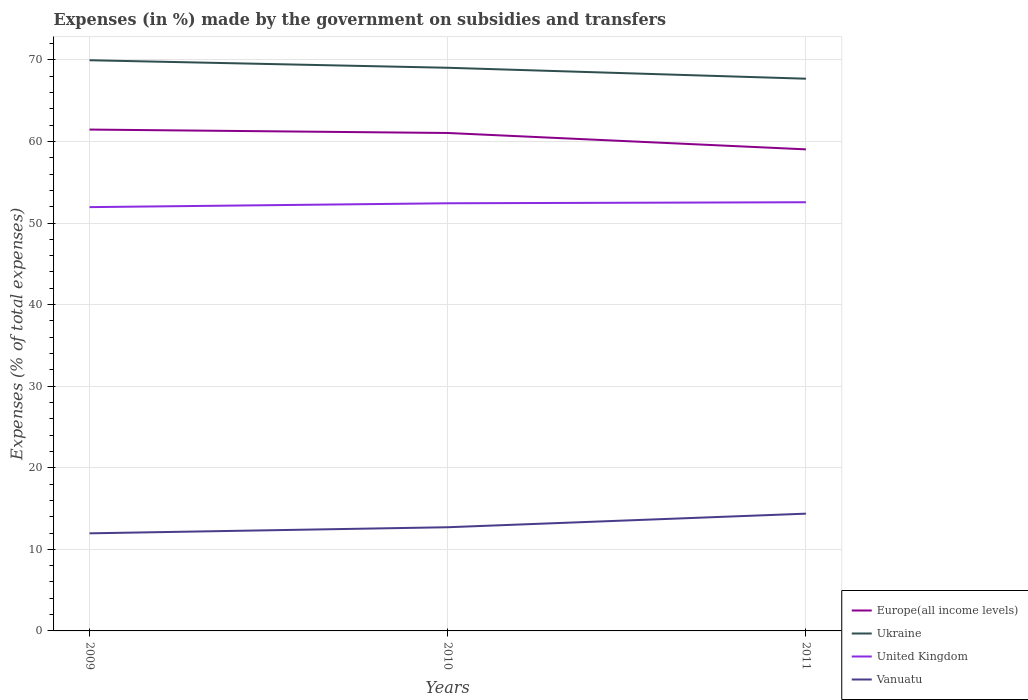Does the line corresponding to United Kingdom intersect with the line corresponding to Europe(all income levels)?
Your response must be concise. No. Across all years, what is the maximum percentage of expenses made by the government on subsidies and transfers in Ukraine?
Provide a succinct answer. 67.69. What is the total percentage of expenses made by the government on subsidies and transfers in Europe(all income levels) in the graph?
Offer a very short reply. 0.42. What is the difference between the highest and the second highest percentage of expenses made by the government on subsidies and transfers in Ukraine?
Provide a short and direct response. 2.26. What is the difference between the highest and the lowest percentage of expenses made by the government on subsidies and transfers in Ukraine?
Keep it short and to the point. 2. Is the percentage of expenses made by the government on subsidies and transfers in United Kingdom strictly greater than the percentage of expenses made by the government on subsidies and transfers in Ukraine over the years?
Your response must be concise. Yes. How many lines are there?
Make the answer very short. 4. Does the graph contain any zero values?
Provide a short and direct response. No. How many legend labels are there?
Your answer should be very brief. 4. What is the title of the graph?
Ensure brevity in your answer.  Expenses (in %) made by the government on subsidies and transfers. What is the label or title of the X-axis?
Your answer should be very brief. Years. What is the label or title of the Y-axis?
Make the answer very short. Expenses (% of total expenses). What is the Expenses (% of total expenses) in Europe(all income levels) in 2009?
Keep it short and to the point. 61.46. What is the Expenses (% of total expenses) in Ukraine in 2009?
Provide a succinct answer. 69.96. What is the Expenses (% of total expenses) in United Kingdom in 2009?
Give a very brief answer. 51.95. What is the Expenses (% of total expenses) in Vanuatu in 2009?
Give a very brief answer. 11.96. What is the Expenses (% of total expenses) of Europe(all income levels) in 2010?
Keep it short and to the point. 61.04. What is the Expenses (% of total expenses) in Ukraine in 2010?
Keep it short and to the point. 69.03. What is the Expenses (% of total expenses) of United Kingdom in 2010?
Provide a short and direct response. 52.42. What is the Expenses (% of total expenses) of Vanuatu in 2010?
Your answer should be very brief. 12.71. What is the Expenses (% of total expenses) of Europe(all income levels) in 2011?
Your response must be concise. 59.03. What is the Expenses (% of total expenses) in Ukraine in 2011?
Your response must be concise. 67.69. What is the Expenses (% of total expenses) of United Kingdom in 2011?
Make the answer very short. 52.55. What is the Expenses (% of total expenses) of Vanuatu in 2011?
Your answer should be very brief. 14.37. Across all years, what is the maximum Expenses (% of total expenses) in Europe(all income levels)?
Keep it short and to the point. 61.46. Across all years, what is the maximum Expenses (% of total expenses) in Ukraine?
Offer a terse response. 69.96. Across all years, what is the maximum Expenses (% of total expenses) of United Kingdom?
Your response must be concise. 52.55. Across all years, what is the maximum Expenses (% of total expenses) of Vanuatu?
Keep it short and to the point. 14.37. Across all years, what is the minimum Expenses (% of total expenses) in Europe(all income levels)?
Your answer should be compact. 59.03. Across all years, what is the minimum Expenses (% of total expenses) in Ukraine?
Your answer should be very brief. 67.69. Across all years, what is the minimum Expenses (% of total expenses) of United Kingdom?
Your answer should be compact. 51.95. Across all years, what is the minimum Expenses (% of total expenses) in Vanuatu?
Make the answer very short. 11.96. What is the total Expenses (% of total expenses) of Europe(all income levels) in the graph?
Make the answer very short. 181.52. What is the total Expenses (% of total expenses) in Ukraine in the graph?
Your answer should be compact. 206.68. What is the total Expenses (% of total expenses) of United Kingdom in the graph?
Provide a succinct answer. 156.92. What is the total Expenses (% of total expenses) in Vanuatu in the graph?
Provide a short and direct response. 39.05. What is the difference between the Expenses (% of total expenses) in Europe(all income levels) in 2009 and that in 2010?
Offer a terse response. 0.42. What is the difference between the Expenses (% of total expenses) in Ukraine in 2009 and that in 2010?
Provide a short and direct response. 0.92. What is the difference between the Expenses (% of total expenses) in United Kingdom in 2009 and that in 2010?
Your answer should be very brief. -0.47. What is the difference between the Expenses (% of total expenses) of Vanuatu in 2009 and that in 2010?
Your answer should be compact. -0.75. What is the difference between the Expenses (% of total expenses) in Europe(all income levels) in 2009 and that in 2011?
Make the answer very short. 2.43. What is the difference between the Expenses (% of total expenses) in Ukraine in 2009 and that in 2011?
Provide a succinct answer. 2.26. What is the difference between the Expenses (% of total expenses) of United Kingdom in 2009 and that in 2011?
Your answer should be very brief. -0.6. What is the difference between the Expenses (% of total expenses) in Vanuatu in 2009 and that in 2011?
Your answer should be compact. -2.41. What is the difference between the Expenses (% of total expenses) of Europe(all income levels) in 2010 and that in 2011?
Your answer should be compact. 2.01. What is the difference between the Expenses (% of total expenses) of Ukraine in 2010 and that in 2011?
Your response must be concise. 1.34. What is the difference between the Expenses (% of total expenses) of United Kingdom in 2010 and that in 2011?
Offer a very short reply. -0.13. What is the difference between the Expenses (% of total expenses) of Vanuatu in 2010 and that in 2011?
Offer a very short reply. -1.66. What is the difference between the Expenses (% of total expenses) of Europe(all income levels) in 2009 and the Expenses (% of total expenses) of Ukraine in 2010?
Keep it short and to the point. -7.58. What is the difference between the Expenses (% of total expenses) of Europe(all income levels) in 2009 and the Expenses (% of total expenses) of United Kingdom in 2010?
Offer a terse response. 9.03. What is the difference between the Expenses (% of total expenses) of Europe(all income levels) in 2009 and the Expenses (% of total expenses) of Vanuatu in 2010?
Your answer should be very brief. 48.75. What is the difference between the Expenses (% of total expenses) of Ukraine in 2009 and the Expenses (% of total expenses) of United Kingdom in 2010?
Offer a terse response. 17.53. What is the difference between the Expenses (% of total expenses) of Ukraine in 2009 and the Expenses (% of total expenses) of Vanuatu in 2010?
Provide a short and direct response. 57.24. What is the difference between the Expenses (% of total expenses) of United Kingdom in 2009 and the Expenses (% of total expenses) of Vanuatu in 2010?
Your answer should be compact. 39.24. What is the difference between the Expenses (% of total expenses) of Europe(all income levels) in 2009 and the Expenses (% of total expenses) of Ukraine in 2011?
Your response must be concise. -6.24. What is the difference between the Expenses (% of total expenses) of Europe(all income levels) in 2009 and the Expenses (% of total expenses) of United Kingdom in 2011?
Ensure brevity in your answer.  8.91. What is the difference between the Expenses (% of total expenses) of Europe(all income levels) in 2009 and the Expenses (% of total expenses) of Vanuatu in 2011?
Make the answer very short. 47.08. What is the difference between the Expenses (% of total expenses) in Ukraine in 2009 and the Expenses (% of total expenses) in United Kingdom in 2011?
Make the answer very short. 17.41. What is the difference between the Expenses (% of total expenses) in Ukraine in 2009 and the Expenses (% of total expenses) in Vanuatu in 2011?
Give a very brief answer. 55.58. What is the difference between the Expenses (% of total expenses) of United Kingdom in 2009 and the Expenses (% of total expenses) of Vanuatu in 2011?
Keep it short and to the point. 37.57. What is the difference between the Expenses (% of total expenses) in Europe(all income levels) in 2010 and the Expenses (% of total expenses) in Ukraine in 2011?
Your response must be concise. -6.65. What is the difference between the Expenses (% of total expenses) in Europe(all income levels) in 2010 and the Expenses (% of total expenses) in United Kingdom in 2011?
Keep it short and to the point. 8.49. What is the difference between the Expenses (% of total expenses) in Europe(all income levels) in 2010 and the Expenses (% of total expenses) in Vanuatu in 2011?
Give a very brief answer. 46.66. What is the difference between the Expenses (% of total expenses) of Ukraine in 2010 and the Expenses (% of total expenses) of United Kingdom in 2011?
Ensure brevity in your answer.  16.48. What is the difference between the Expenses (% of total expenses) in Ukraine in 2010 and the Expenses (% of total expenses) in Vanuatu in 2011?
Offer a terse response. 54.66. What is the difference between the Expenses (% of total expenses) in United Kingdom in 2010 and the Expenses (% of total expenses) in Vanuatu in 2011?
Provide a short and direct response. 38.05. What is the average Expenses (% of total expenses) of Europe(all income levels) per year?
Provide a succinct answer. 60.51. What is the average Expenses (% of total expenses) of Ukraine per year?
Your response must be concise. 68.89. What is the average Expenses (% of total expenses) of United Kingdom per year?
Keep it short and to the point. 52.31. What is the average Expenses (% of total expenses) in Vanuatu per year?
Your answer should be very brief. 13.02. In the year 2009, what is the difference between the Expenses (% of total expenses) of Europe(all income levels) and Expenses (% of total expenses) of Ukraine?
Your answer should be very brief. -8.5. In the year 2009, what is the difference between the Expenses (% of total expenses) in Europe(all income levels) and Expenses (% of total expenses) in United Kingdom?
Provide a short and direct response. 9.51. In the year 2009, what is the difference between the Expenses (% of total expenses) of Europe(all income levels) and Expenses (% of total expenses) of Vanuatu?
Your response must be concise. 49.49. In the year 2009, what is the difference between the Expenses (% of total expenses) in Ukraine and Expenses (% of total expenses) in United Kingdom?
Keep it short and to the point. 18.01. In the year 2009, what is the difference between the Expenses (% of total expenses) of Ukraine and Expenses (% of total expenses) of Vanuatu?
Ensure brevity in your answer.  57.99. In the year 2009, what is the difference between the Expenses (% of total expenses) of United Kingdom and Expenses (% of total expenses) of Vanuatu?
Provide a short and direct response. 39.98. In the year 2010, what is the difference between the Expenses (% of total expenses) in Europe(all income levels) and Expenses (% of total expenses) in Ukraine?
Make the answer very short. -7.99. In the year 2010, what is the difference between the Expenses (% of total expenses) in Europe(all income levels) and Expenses (% of total expenses) in United Kingdom?
Provide a short and direct response. 8.62. In the year 2010, what is the difference between the Expenses (% of total expenses) in Europe(all income levels) and Expenses (% of total expenses) in Vanuatu?
Your response must be concise. 48.33. In the year 2010, what is the difference between the Expenses (% of total expenses) of Ukraine and Expenses (% of total expenses) of United Kingdom?
Provide a short and direct response. 16.61. In the year 2010, what is the difference between the Expenses (% of total expenses) of Ukraine and Expenses (% of total expenses) of Vanuatu?
Keep it short and to the point. 56.32. In the year 2010, what is the difference between the Expenses (% of total expenses) of United Kingdom and Expenses (% of total expenses) of Vanuatu?
Keep it short and to the point. 39.71. In the year 2011, what is the difference between the Expenses (% of total expenses) of Europe(all income levels) and Expenses (% of total expenses) of Ukraine?
Ensure brevity in your answer.  -8.66. In the year 2011, what is the difference between the Expenses (% of total expenses) of Europe(all income levels) and Expenses (% of total expenses) of United Kingdom?
Ensure brevity in your answer.  6.48. In the year 2011, what is the difference between the Expenses (% of total expenses) in Europe(all income levels) and Expenses (% of total expenses) in Vanuatu?
Your answer should be compact. 44.66. In the year 2011, what is the difference between the Expenses (% of total expenses) of Ukraine and Expenses (% of total expenses) of United Kingdom?
Ensure brevity in your answer.  15.14. In the year 2011, what is the difference between the Expenses (% of total expenses) in Ukraine and Expenses (% of total expenses) in Vanuatu?
Give a very brief answer. 53.32. In the year 2011, what is the difference between the Expenses (% of total expenses) in United Kingdom and Expenses (% of total expenses) in Vanuatu?
Ensure brevity in your answer.  38.17. What is the ratio of the Expenses (% of total expenses) of Europe(all income levels) in 2009 to that in 2010?
Keep it short and to the point. 1.01. What is the ratio of the Expenses (% of total expenses) in Ukraine in 2009 to that in 2010?
Provide a succinct answer. 1.01. What is the ratio of the Expenses (% of total expenses) in United Kingdom in 2009 to that in 2010?
Provide a succinct answer. 0.99. What is the ratio of the Expenses (% of total expenses) of Vanuatu in 2009 to that in 2010?
Provide a short and direct response. 0.94. What is the ratio of the Expenses (% of total expenses) in Europe(all income levels) in 2009 to that in 2011?
Give a very brief answer. 1.04. What is the ratio of the Expenses (% of total expenses) in Ukraine in 2009 to that in 2011?
Provide a short and direct response. 1.03. What is the ratio of the Expenses (% of total expenses) in Vanuatu in 2009 to that in 2011?
Make the answer very short. 0.83. What is the ratio of the Expenses (% of total expenses) of Europe(all income levels) in 2010 to that in 2011?
Your answer should be compact. 1.03. What is the ratio of the Expenses (% of total expenses) in Ukraine in 2010 to that in 2011?
Give a very brief answer. 1.02. What is the ratio of the Expenses (% of total expenses) in United Kingdom in 2010 to that in 2011?
Give a very brief answer. 1. What is the ratio of the Expenses (% of total expenses) in Vanuatu in 2010 to that in 2011?
Ensure brevity in your answer.  0.88. What is the difference between the highest and the second highest Expenses (% of total expenses) in Europe(all income levels)?
Offer a terse response. 0.42. What is the difference between the highest and the second highest Expenses (% of total expenses) in Ukraine?
Offer a terse response. 0.92. What is the difference between the highest and the second highest Expenses (% of total expenses) of United Kingdom?
Give a very brief answer. 0.13. What is the difference between the highest and the second highest Expenses (% of total expenses) in Vanuatu?
Your response must be concise. 1.66. What is the difference between the highest and the lowest Expenses (% of total expenses) of Europe(all income levels)?
Your response must be concise. 2.43. What is the difference between the highest and the lowest Expenses (% of total expenses) in Ukraine?
Offer a very short reply. 2.26. What is the difference between the highest and the lowest Expenses (% of total expenses) of United Kingdom?
Your response must be concise. 0.6. What is the difference between the highest and the lowest Expenses (% of total expenses) in Vanuatu?
Offer a very short reply. 2.41. 